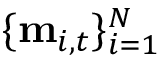Convert formula to latex. <formula><loc_0><loc_0><loc_500><loc_500>\{ m _ { i , t } \} _ { i = 1 } ^ { N }</formula> 